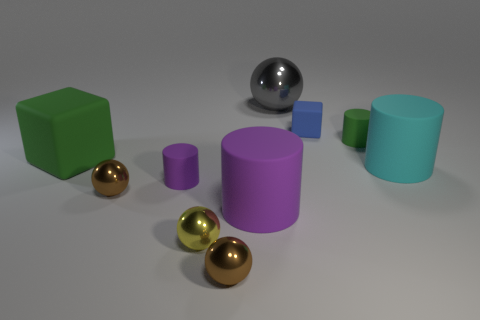What is the color of the other large matte object that is the same shape as the big cyan thing?
Your answer should be very brief. Purple. What number of things are blue metal cubes or metallic things behind the small block?
Your answer should be very brief. 1. Is the number of brown shiny objects that are in front of the yellow shiny ball less than the number of large cyan matte cylinders?
Your answer should be very brief. No. How big is the shiny object on the right side of the big matte cylinder in front of the big cyan thing in front of the tiny blue object?
Provide a succinct answer. Large. What is the color of the sphere that is right of the yellow ball and behind the yellow sphere?
Offer a very short reply. Gray. What number of green rubber cylinders are there?
Keep it short and to the point. 1. Is there any other thing that is the same size as the green matte block?
Offer a terse response. Yes. Is the material of the green cylinder the same as the yellow object?
Offer a terse response. No. There is a brown metallic ball that is in front of the big purple cylinder; is it the same size as the rubber object on the right side of the tiny green object?
Your response must be concise. No. Is the number of large red metal balls less than the number of tiny cylinders?
Provide a succinct answer. Yes. 